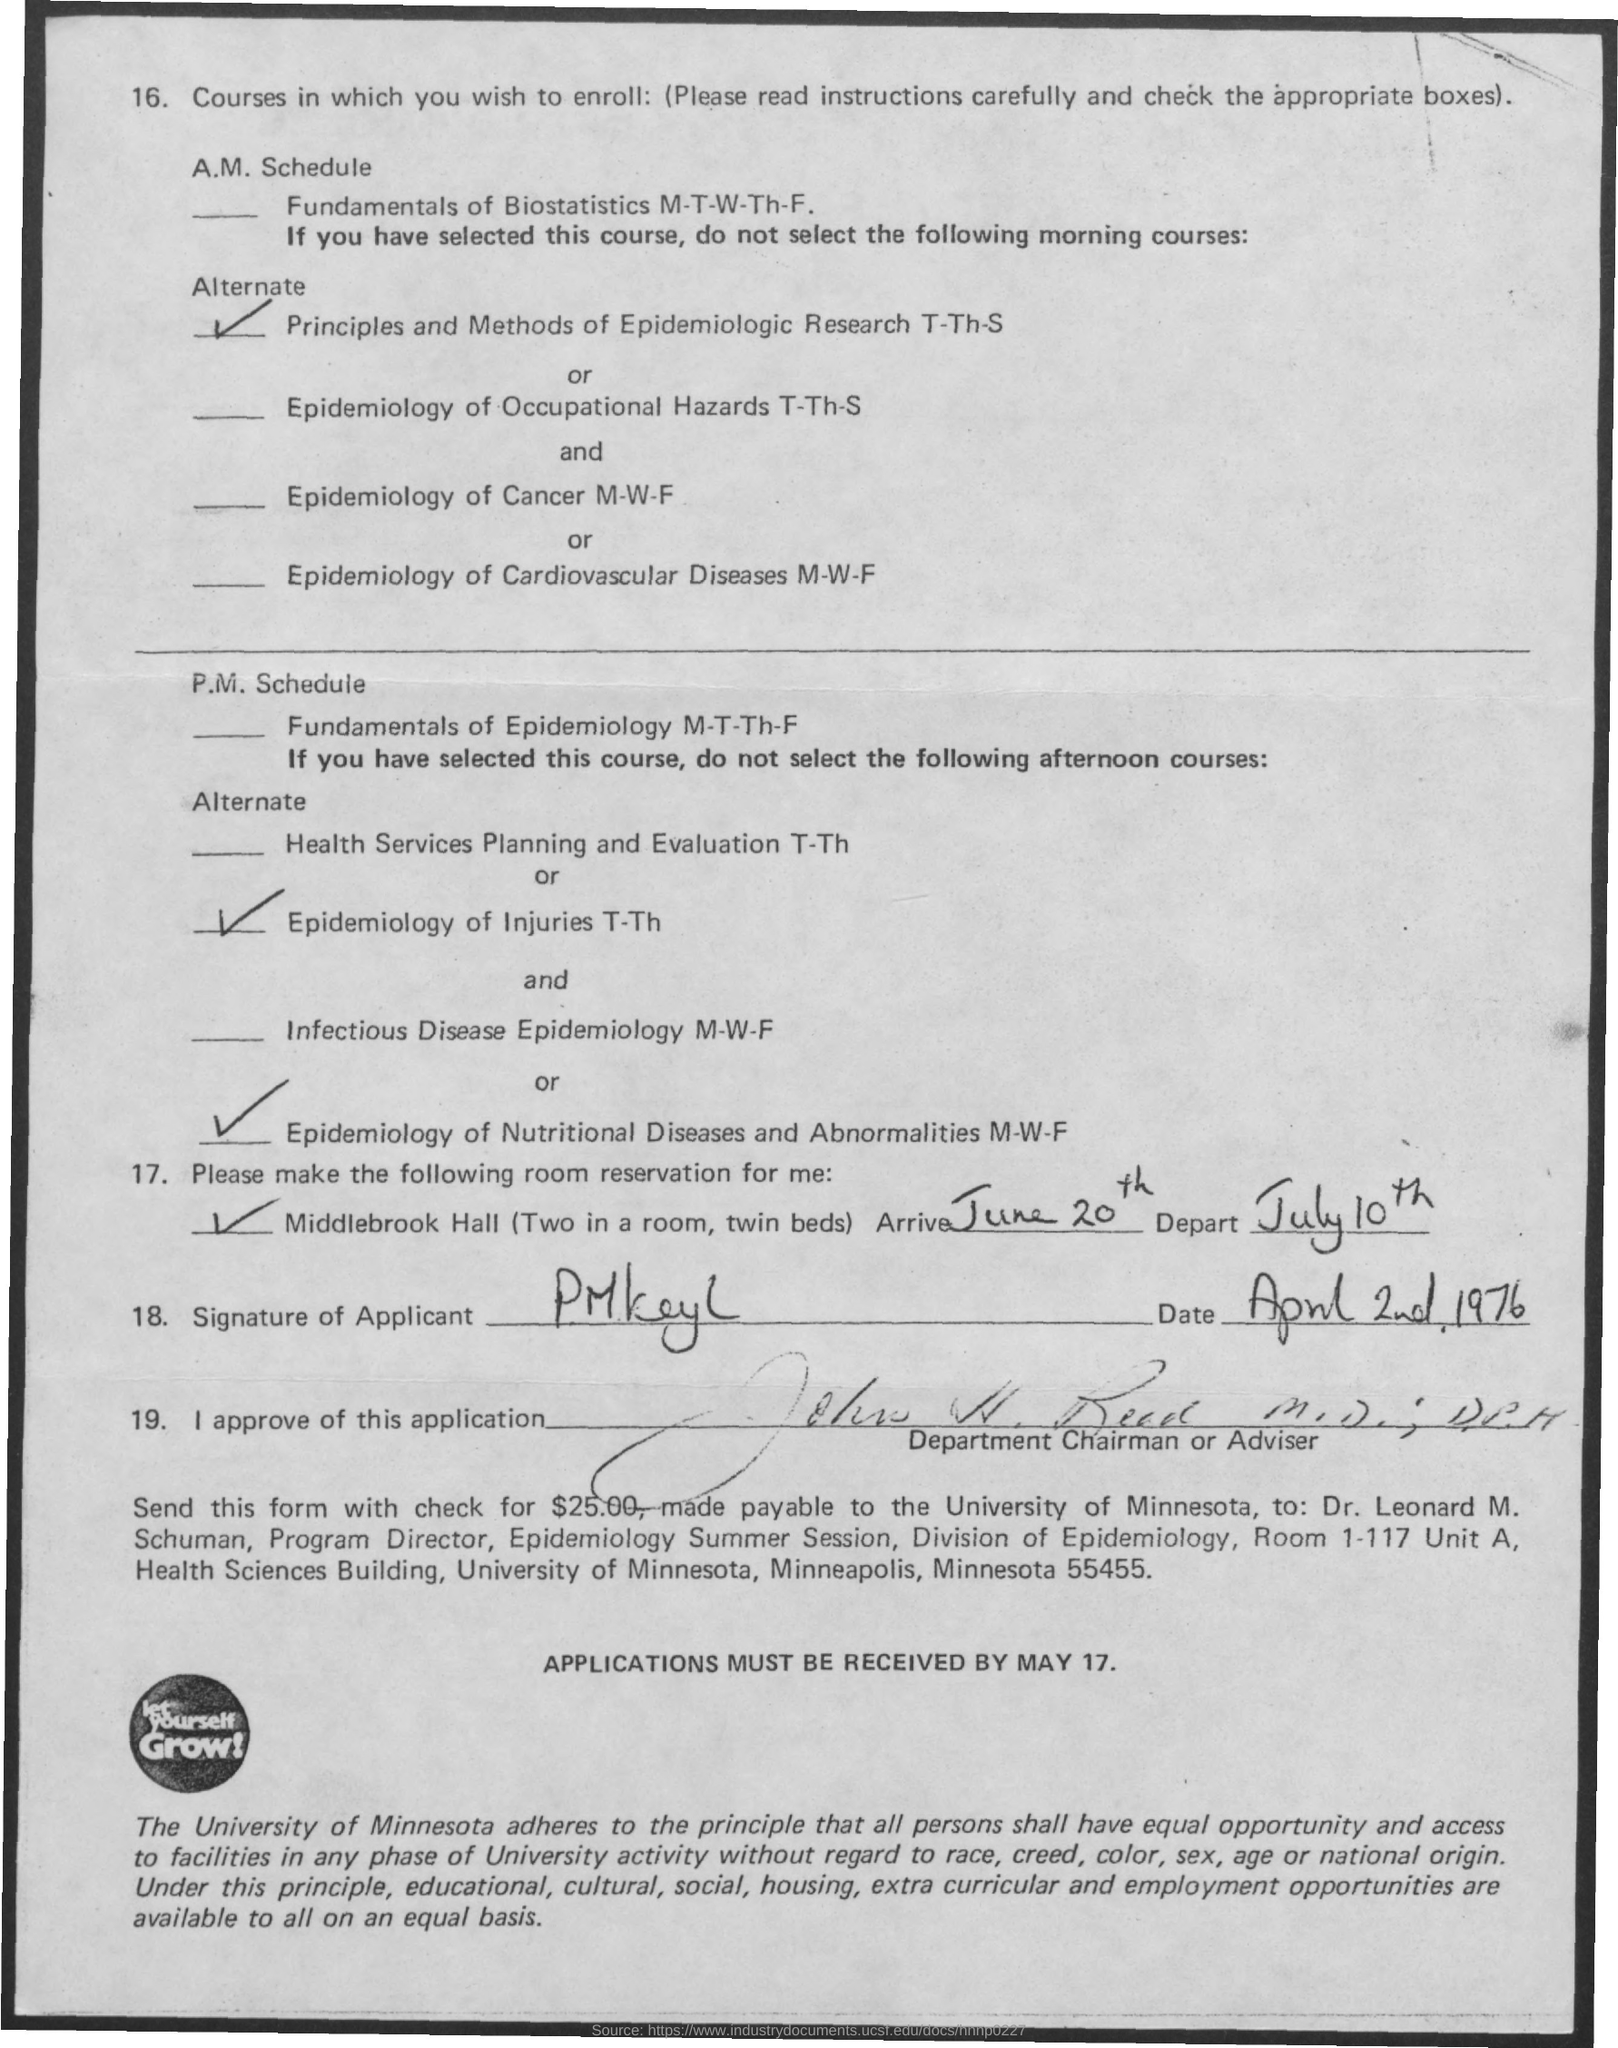What is the arrive date mentioned in the given letter ?
Ensure brevity in your answer.  June 20th. What is the depart date mentioned in the given letter ?
Ensure brevity in your answer.  July 10th. On which date the signature was done in the letter ?
Your answer should be compact. April 2nd, 1976. 